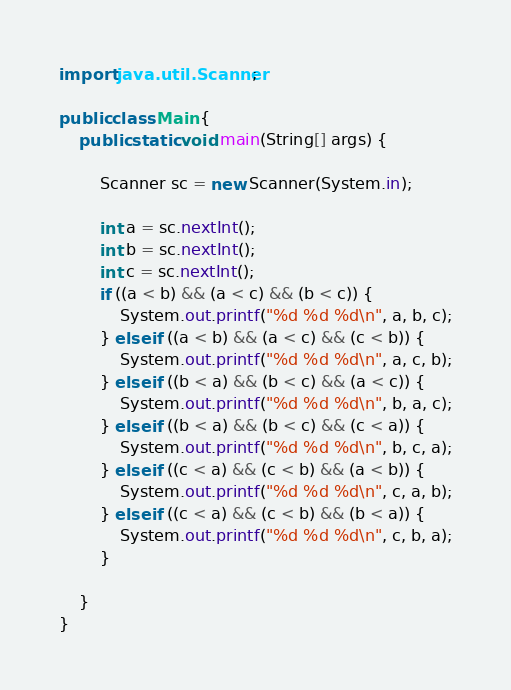<code> <loc_0><loc_0><loc_500><loc_500><_Java_>import java.util.Scanner;

public class Main {
	public static void main(String[] args) {

		Scanner sc = new Scanner(System.in);

		int a = sc.nextInt();
		int b = sc.nextInt();
		int c = sc.nextInt();
		if ((a < b) && (a < c) && (b < c)) {
			System.out.printf("%d %d %d\n", a, b, c);
		} else if ((a < b) && (a < c) && (c < b)) {
			System.out.printf("%d %d %d\n", a, c, b);
		} else if ((b < a) && (b < c) && (a < c)) {
			System.out.printf("%d %d %d\n", b, a, c);
		} else if ((b < a) && (b < c) && (c < a)) {
			System.out.printf("%d %d %d\n", b, c, a);
		} else if ((c < a) && (c < b) && (a < b)) {
			System.out.printf("%d %d %d\n", c, a, b);
		} else if ((c < a) && (c < b) && (b < a)) {
			System.out.printf("%d %d %d\n", c, b, a);
		}

	}
}</code> 